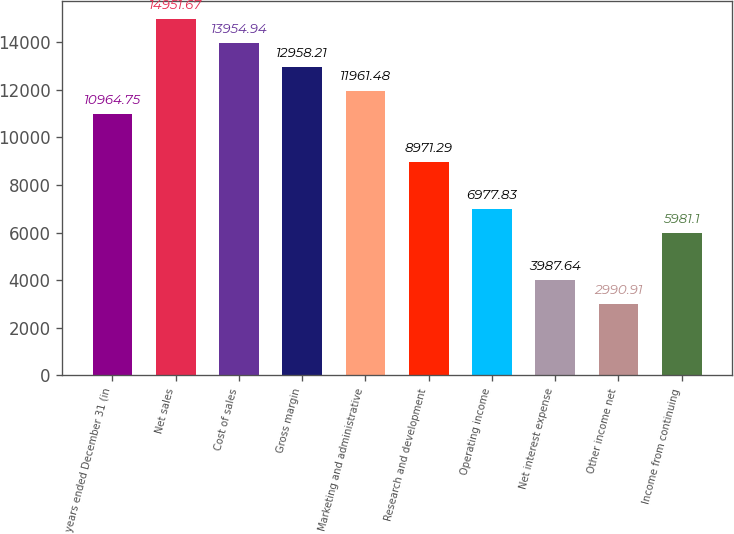<chart> <loc_0><loc_0><loc_500><loc_500><bar_chart><fcel>years ended December 31 (in<fcel>Net sales<fcel>Cost of sales<fcel>Gross margin<fcel>Marketing and administrative<fcel>Research and development<fcel>Operating income<fcel>Net interest expense<fcel>Other income net<fcel>Income from continuing<nl><fcel>10964.8<fcel>14951.7<fcel>13954.9<fcel>12958.2<fcel>11961.5<fcel>8971.29<fcel>6977.83<fcel>3987.64<fcel>2990.91<fcel>5981.1<nl></chart> 